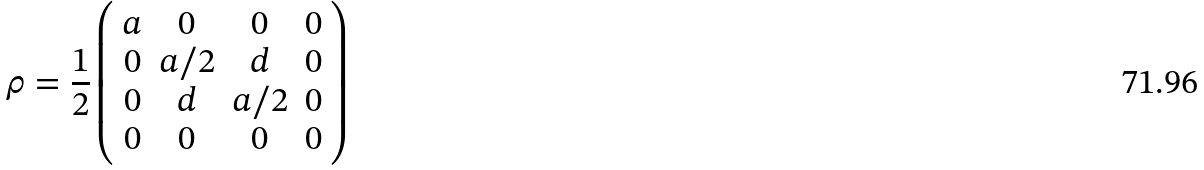Convert formula to latex. <formula><loc_0><loc_0><loc_500><loc_500>\rho = \frac { 1 } { 2 } \left ( \begin{array} { c c c c } a & 0 & 0 & 0 \\ 0 & a / 2 & d & 0 \\ 0 & d & a / 2 & 0 \\ 0 & 0 & 0 & 0 \\ \end{array} \right )</formula> 